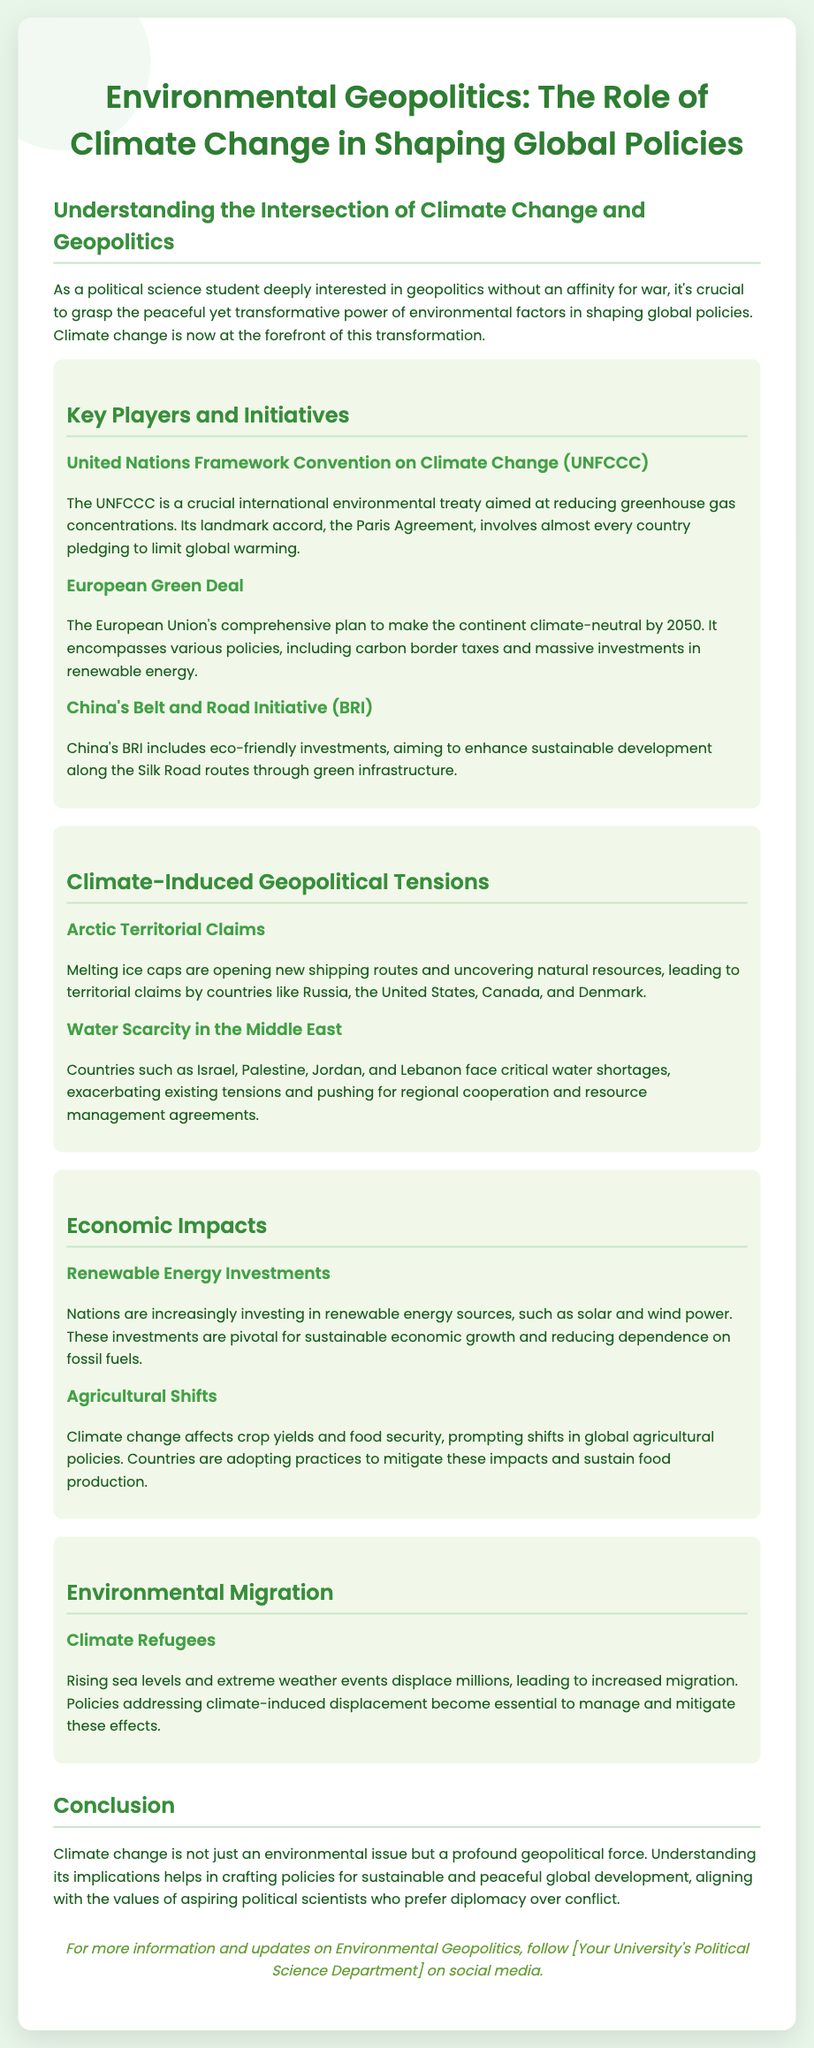What is the title of the flyer? The title is prominently displayed at the top of the flyer.
Answer: Environmental Geopolitics: The Role of Climate Change in Shaping Global Policies What is the main objective of the UNFCCC? The document states that the UNFCCC is aimed at reducing greenhouse gas concentrations.
Answer: Reducing greenhouse gas concentrations By what year does the European Green Deal aim to make the EU climate-neutral? The specific year is mentioned in the section about the European Green Deal.
Answer: 2050 What geographical area is highlighted for climate-induced geopolitical tensions due to melting ice caps? The section discusses specific territorial claims due to climate impacts in a particular region.
Answer: Arctic Which countries face critical water shortages as mentioned in the flyer? The document lists several countries affected by water scarcity in the Middle East.
Answer: Israel, Palestine, Jordan, Lebanon What type of energy investments are nations increasingly making? This is found in the section discussing economic impacts in the context of climate change.
Answer: Renewable energy What is a consequence of rising sea levels mentioned in the flyer? The flyer discusses the effects of rising sea levels on population movement.
Answer: Climate refugees What does the document suggest about climate change's role in global politics? The conclusion summarizes the significance of climate change beyond just environmental issues.
Answer: A profound geopolitical force 